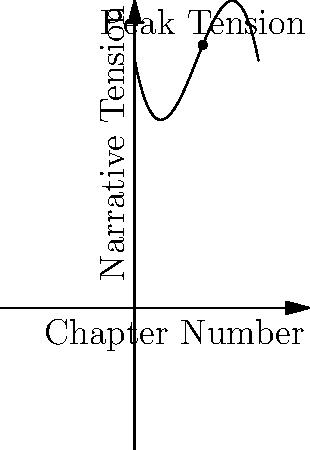In the polynomial graph representing the relationship between chapter length and narrative tension in a novel, where $f(x) = -0.1x^3 + 1.5x^2 - 5x + 20$, at which chapter does the narrative tension reach its peak? Explain the literary significance of this point in relation to the novel's structure. To find the peak of the narrative tension, we need to follow these steps:

1. Find the derivative of the function: $f'(x) = -0.3x^2 + 3x - 5$

2. Set the derivative to zero and solve for x:
   $-0.3x^2 + 3x - 5 = 0$
   
3. Using the quadratic formula, we get:
   $x = \frac{-3 \pm \sqrt{3^2 - 4(-0.3)(-5)}}{2(-0.3)}$
   $x \approx 5.5$ or $x \approx 3.0$

4. The second derivative $f''(x) = -0.6x + 3$ is negative at $x = 5.5$, confirming it's a maximum.

5. Therefore, the peak tension occurs at chapter 5.5.

Literarily, this point signifies the climax of the novel. It's where the conflict reaches its highest intensity, often marking a turning point in the narrative. The gradual build-up before this point represents rising action, while the decline afterwards indicates falling action and resolution. This structure aligns with the classical dramatic arc, demonstrating how mathematical modeling can reveal underlying patterns in narrative composition.
Answer: Chapter 5.5; represents the novel's climax and peak narrative tension. 